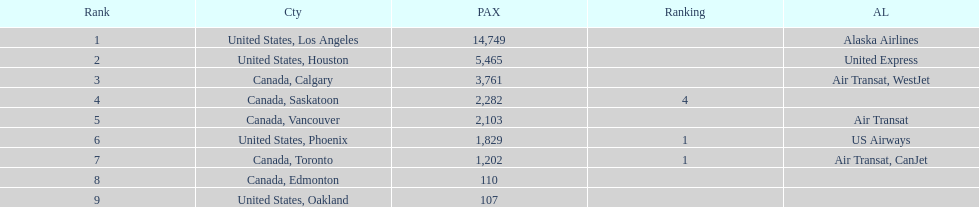Los angeles and what other city had about 19,000 passenger combined Canada, Calgary. 